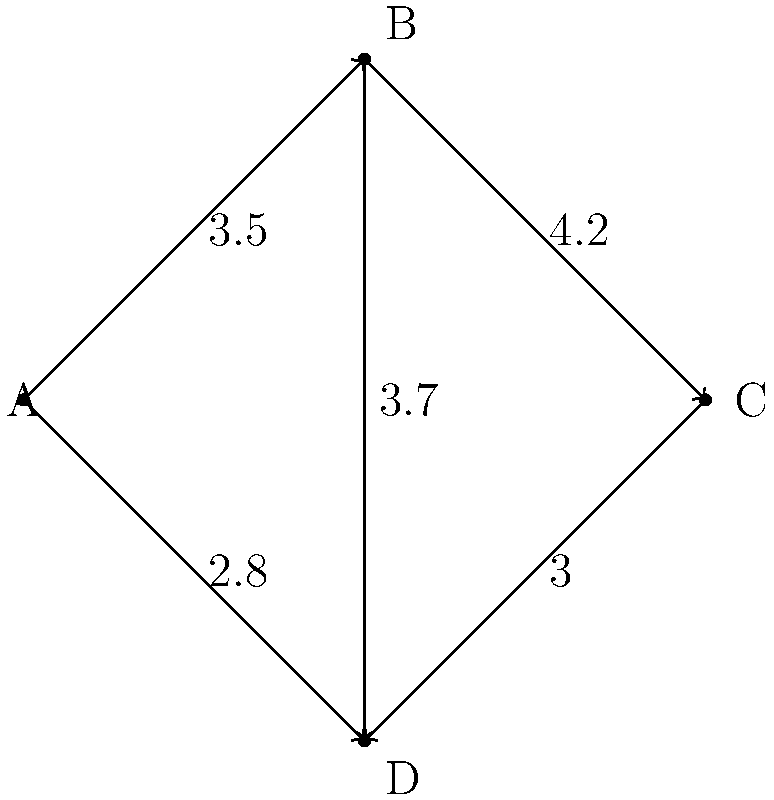As a makeup expert, you're advising a store on optimizing their product placement. The store layout is represented by a weighted graph where vertices (A, B, C, D) are shelves, and edges represent customer traffic patterns with weights indicating traffic intensity. What is the maximum spanning tree weight, representing the optimal shelving configuration for maximum customer exposure? To find the maximum spanning tree, we'll use Kruskal's algorithm in reverse (selecting the heaviest edges first instead of the lightest):

1. List all edges in descending order of weight:
   B-C (4.2), B-D (3.7), A-B (3.5), C-D (3.0), A-D (2.8)

2. Start with an empty set of edges and add edges that don't create cycles:
   - Add B-C (4.2)
   - Add B-D (3.7)
   - Add A-B (3.5)

3. We now have a spanning tree with 3 edges (the minimum required for 4 vertices).

4. Calculate the total weight:
   $4.2 + 3.7 + 3.5 = 11.4$

This maximum spanning tree represents the optimal shelving configuration, connecting all shelves while maximizing customer exposure along the busiest paths.
Answer: 11.4 